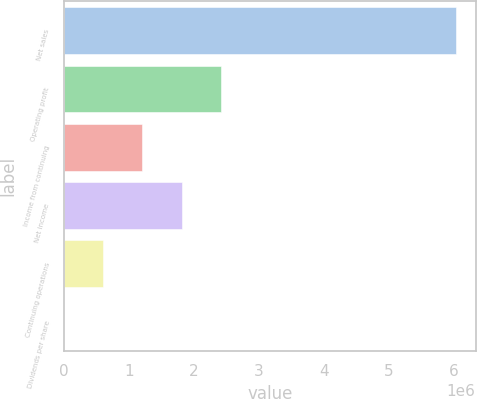Convert chart to OTSL. <chart><loc_0><loc_0><loc_500><loc_500><bar_chart><fcel>Net sales<fcel>Operating profit<fcel>Income from continuing<fcel>Net income<fcel>Continuing operations<fcel>Dividends per share<nl><fcel>6.0282e+06<fcel>2.41128e+06<fcel>1.20564e+06<fcel>1.80846e+06<fcel>602820<fcel>0.44<nl></chart> 